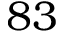Convert formula to latex. <formula><loc_0><loc_0><loc_500><loc_500>8 3</formula> 